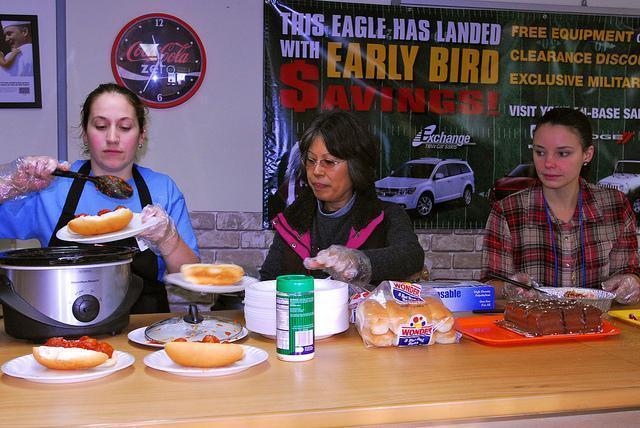How many people are visible?
Give a very brief answer. 3. 